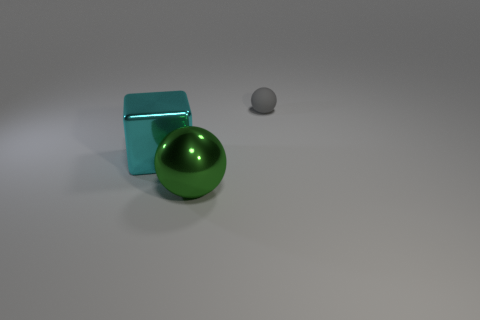There is a green object that is the same shape as the small gray thing; what is its material? The green object appears to have a glossy surface with light reflections similar to that of polished metal, indicating that it is likely made of a metallic material. 